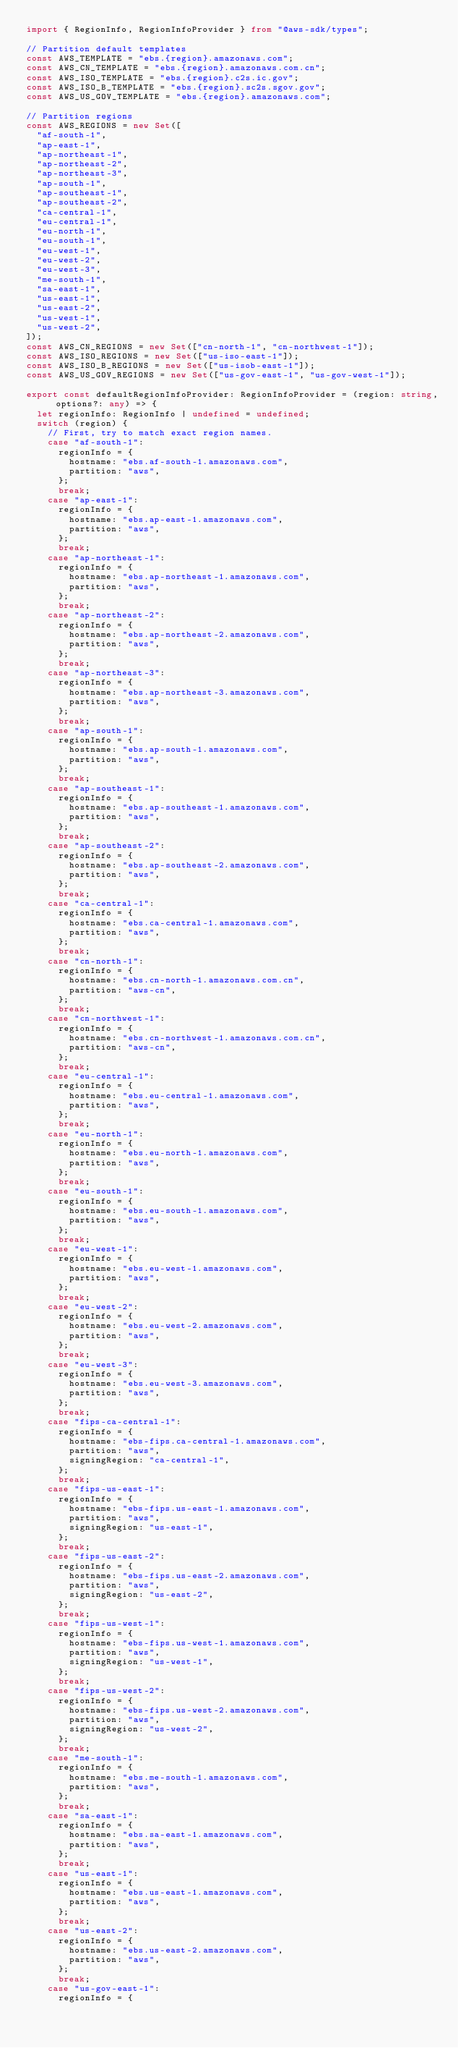Convert code to text. <code><loc_0><loc_0><loc_500><loc_500><_TypeScript_>import { RegionInfo, RegionInfoProvider } from "@aws-sdk/types";

// Partition default templates
const AWS_TEMPLATE = "ebs.{region}.amazonaws.com";
const AWS_CN_TEMPLATE = "ebs.{region}.amazonaws.com.cn";
const AWS_ISO_TEMPLATE = "ebs.{region}.c2s.ic.gov";
const AWS_ISO_B_TEMPLATE = "ebs.{region}.sc2s.sgov.gov";
const AWS_US_GOV_TEMPLATE = "ebs.{region}.amazonaws.com";

// Partition regions
const AWS_REGIONS = new Set([
  "af-south-1",
  "ap-east-1",
  "ap-northeast-1",
  "ap-northeast-2",
  "ap-northeast-3",
  "ap-south-1",
  "ap-southeast-1",
  "ap-southeast-2",
  "ca-central-1",
  "eu-central-1",
  "eu-north-1",
  "eu-south-1",
  "eu-west-1",
  "eu-west-2",
  "eu-west-3",
  "me-south-1",
  "sa-east-1",
  "us-east-1",
  "us-east-2",
  "us-west-1",
  "us-west-2",
]);
const AWS_CN_REGIONS = new Set(["cn-north-1", "cn-northwest-1"]);
const AWS_ISO_REGIONS = new Set(["us-iso-east-1"]);
const AWS_ISO_B_REGIONS = new Set(["us-isob-east-1"]);
const AWS_US_GOV_REGIONS = new Set(["us-gov-east-1", "us-gov-west-1"]);

export const defaultRegionInfoProvider: RegionInfoProvider = (region: string, options?: any) => {
  let regionInfo: RegionInfo | undefined = undefined;
  switch (region) {
    // First, try to match exact region names.
    case "af-south-1":
      regionInfo = {
        hostname: "ebs.af-south-1.amazonaws.com",
        partition: "aws",
      };
      break;
    case "ap-east-1":
      regionInfo = {
        hostname: "ebs.ap-east-1.amazonaws.com",
        partition: "aws",
      };
      break;
    case "ap-northeast-1":
      regionInfo = {
        hostname: "ebs.ap-northeast-1.amazonaws.com",
        partition: "aws",
      };
      break;
    case "ap-northeast-2":
      regionInfo = {
        hostname: "ebs.ap-northeast-2.amazonaws.com",
        partition: "aws",
      };
      break;
    case "ap-northeast-3":
      regionInfo = {
        hostname: "ebs.ap-northeast-3.amazonaws.com",
        partition: "aws",
      };
      break;
    case "ap-south-1":
      regionInfo = {
        hostname: "ebs.ap-south-1.amazonaws.com",
        partition: "aws",
      };
      break;
    case "ap-southeast-1":
      regionInfo = {
        hostname: "ebs.ap-southeast-1.amazonaws.com",
        partition: "aws",
      };
      break;
    case "ap-southeast-2":
      regionInfo = {
        hostname: "ebs.ap-southeast-2.amazonaws.com",
        partition: "aws",
      };
      break;
    case "ca-central-1":
      regionInfo = {
        hostname: "ebs.ca-central-1.amazonaws.com",
        partition: "aws",
      };
      break;
    case "cn-north-1":
      regionInfo = {
        hostname: "ebs.cn-north-1.amazonaws.com.cn",
        partition: "aws-cn",
      };
      break;
    case "cn-northwest-1":
      regionInfo = {
        hostname: "ebs.cn-northwest-1.amazonaws.com.cn",
        partition: "aws-cn",
      };
      break;
    case "eu-central-1":
      regionInfo = {
        hostname: "ebs.eu-central-1.amazonaws.com",
        partition: "aws",
      };
      break;
    case "eu-north-1":
      regionInfo = {
        hostname: "ebs.eu-north-1.amazonaws.com",
        partition: "aws",
      };
      break;
    case "eu-south-1":
      regionInfo = {
        hostname: "ebs.eu-south-1.amazonaws.com",
        partition: "aws",
      };
      break;
    case "eu-west-1":
      regionInfo = {
        hostname: "ebs.eu-west-1.amazonaws.com",
        partition: "aws",
      };
      break;
    case "eu-west-2":
      regionInfo = {
        hostname: "ebs.eu-west-2.amazonaws.com",
        partition: "aws",
      };
      break;
    case "eu-west-3":
      regionInfo = {
        hostname: "ebs.eu-west-3.amazonaws.com",
        partition: "aws",
      };
      break;
    case "fips-ca-central-1":
      regionInfo = {
        hostname: "ebs-fips.ca-central-1.amazonaws.com",
        partition: "aws",
        signingRegion: "ca-central-1",
      };
      break;
    case "fips-us-east-1":
      regionInfo = {
        hostname: "ebs-fips.us-east-1.amazonaws.com",
        partition: "aws",
        signingRegion: "us-east-1",
      };
      break;
    case "fips-us-east-2":
      regionInfo = {
        hostname: "ebs-fips.us-east-2.amazonaws.com",
        partition: "aws",
        signingRegion: "us-east-2",
      };
      break;
    case "fips-us-west-1":
      regionInfo = {
        hostname: "ebs-fips.us-west-1.amazonaws.com",
        partition: "aws",
        signingRegion: "us-west-1",
      };
      break;
    case "fips-us-west-2":
      regionInfo = {
        hostname: "ebs-fips.us-west-2.amazonaws.com",
        partition: "aws",
        signingRegion: "us-west-2",
      };
      break;
    case "me-south-1":
      regionInfo = {
        hostname: "ebs.me-south-1.amazonaws.com",
        partition: "aws",
      };
      break;
    case "sa-east-1":
      regionInfo = {
        hostname: "ebs.sa-east-1.amazonaws.com",
        partition: "aws",
      };
      break;
    case "us-east-1":
      regionInfo = {
        hostname: "ebs.us-east-1.amazonaws.com",
        partition: "aws",
      };
      break;
    case "us-east-2":
      regionInfo = {
        hostname: "ebs.us-east-2.amazonaws.com",
        partition: "aws",
      };
      break;
    case "us-gov-east-1":
      regionInfo = {</code> 